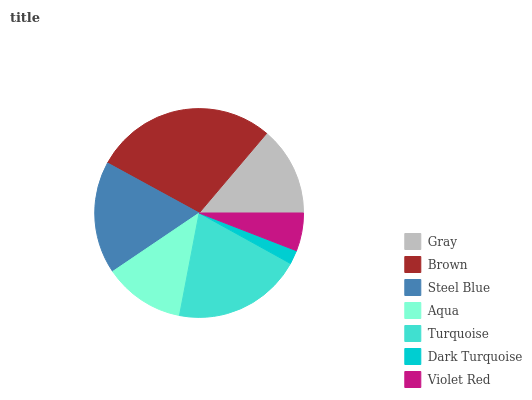Is Dark Turquoise the minimum?
Answer yes or no. Yes. Is Brown the maximum?
Answer yes or no. Yes. Is Steel Blue the minimum?
Answer yes or no. No. Is Steel Blue the maximum?
Answer yes or no. No. Is Brown greater than Steel Blue?
Answer yes or no. Yes. Is Steel Blue less than Brown?
Answer yes or no. Yes. Is Steel Blue greater than Brown?
Answer yes or no. No. Is Brown less than Steel Blue?
Answer yes or no. No. Is Gray the high median?
Answer yes or no. Yes. Is Gray the low median?
Answer yes or no. Yes. Is Brown the high median?
Answer yes or no. No. Is Turquoise the low median?
Answer yes or no. No. 